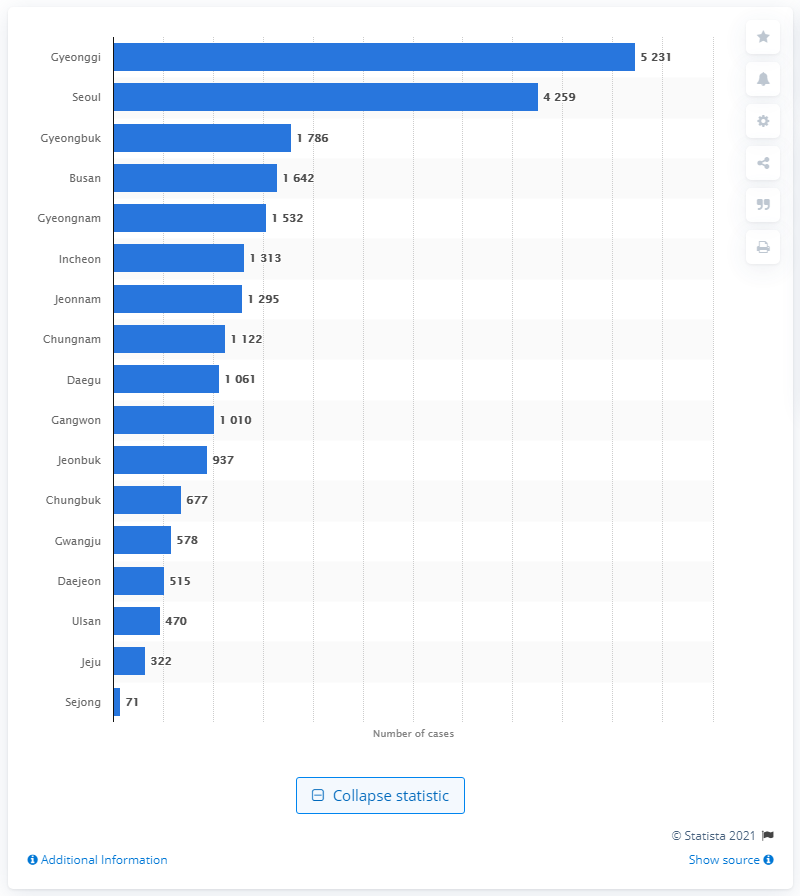Mention a couple of crucial points in this snapshot. In 2019, the number of TB cases in Seoul was 4,259. In 2019, there were 5,231 cases of tuberculosis (TB) reported in Gyeonggi province. The province of Gyeonggi had the highest number of tuberculosis cases in 2019, according to recent statistics. 